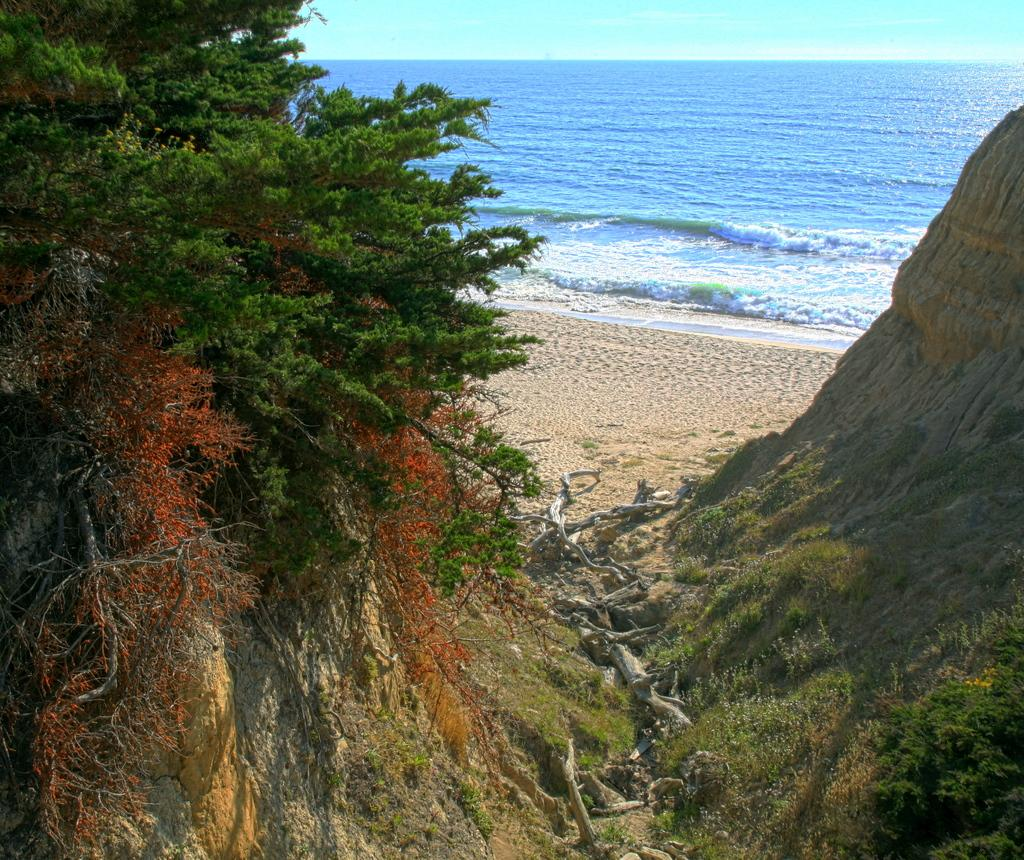What type of vegetation can be seen on the left side of the image? There are trees on the left side of the image. What type of vegetation can be seen on the right side of the image? There are trees on the right side of the image. What natural element is visible in the background of the image? Water is visible in the background of the image. What else can be seen in the background of the image? The sky is visible in the background of the image. Is there any quicksand present in the image? There is no quicksand present in the image. What type of can is visible in the image? There is no can present in the image. 